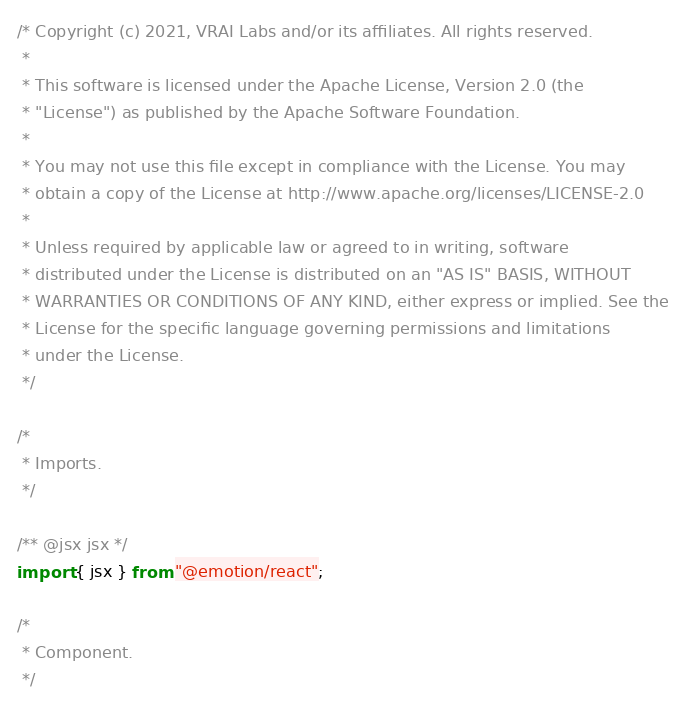<code> <loc_0><loc_0><loc_500><loc_500><_TypeScript_>/* Copyright (c) 2021, VRAI Labs and/or its affiliates. All rights reserved.
 *
 * This software is licensed under the Apache License, Version 2.0 (the
 * "License") as published by the Apache Software Foundation.
 *
 * You may not use this file except in compliance with the License. You may
 * obtain a copy of the License at http://www.apache.org/licenses/LICENSE-2.0
 *
 * Unless required by applicable law or agreed to in writing, software
 * distributed under the License is distributed on an "AS IS" BASIS, WITHOUT
 * WARRANTIES OR CONDITIONS OF ANY KIND, either express or implied. See the
 * License for the specific language governing permissions and limitations
 * under the License.
 */

/*
 * Imports.
 */

/** @jsx jsx */
import { jsx } from "@emotion/react";

/*
 * Component.
 */
</code> 